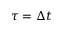<formula> <loc_0><loc_0><loc_500><loc_500>\tau = \Delta t</formula> 